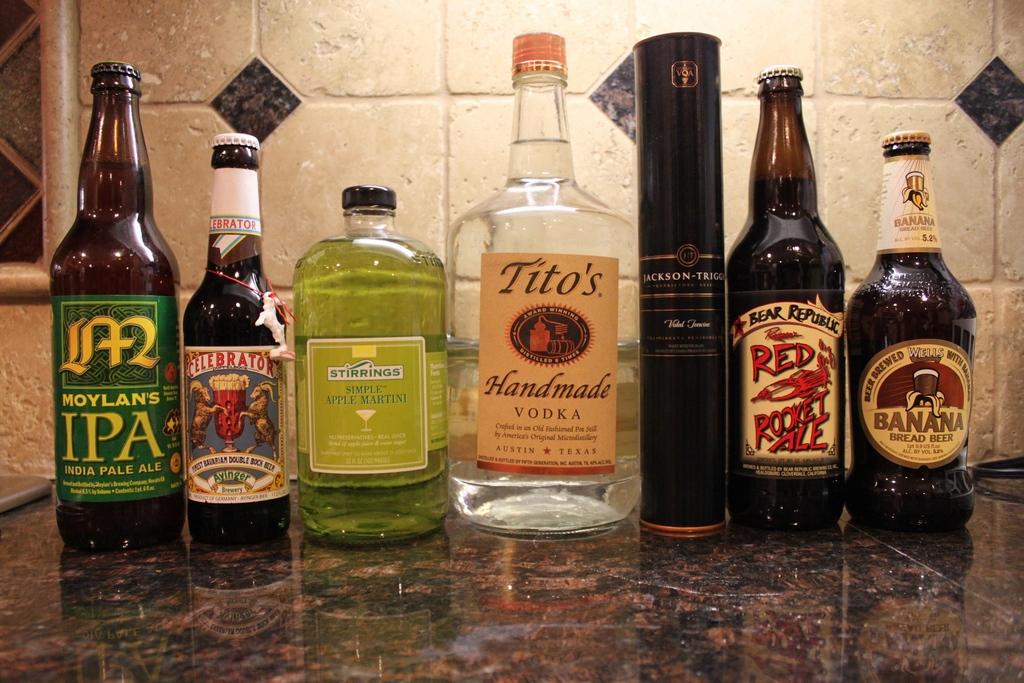What kinds of alcohol are shown on this table?
Provide a short and direct response. Vodka. How many bottles are on this table?
Provide a short and direct response. 7. 